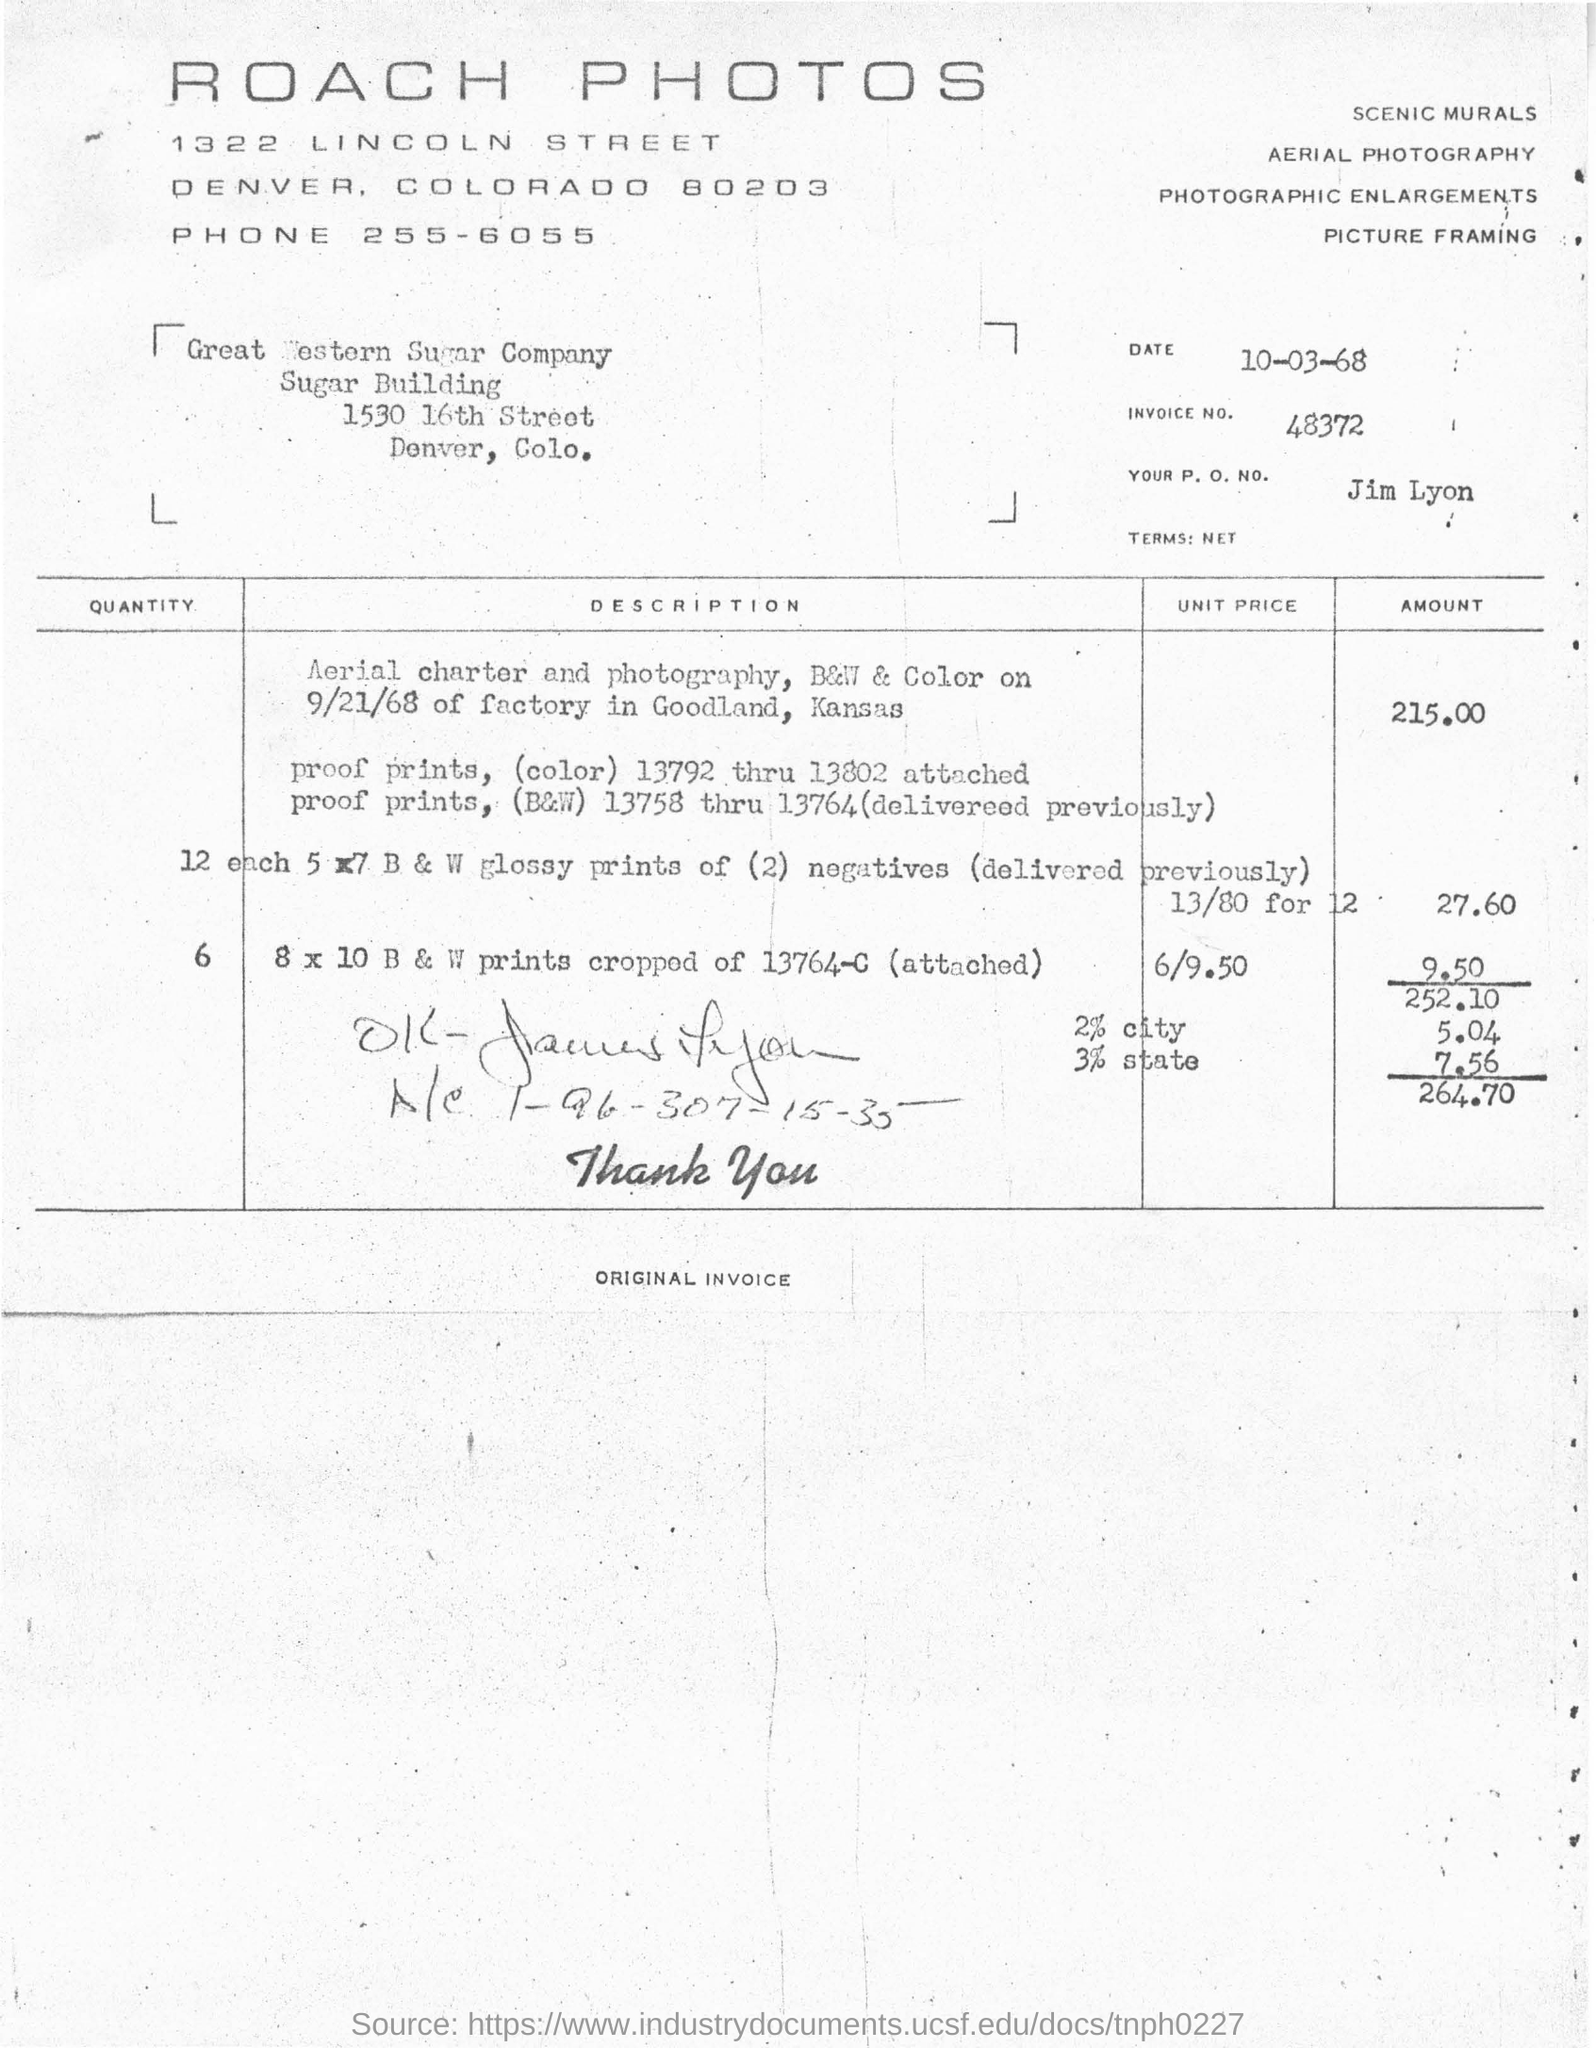What is the date mentioned in the invoice?
Give a very brief answer. 10-03-68. What is the invoice no. given in the document?
Make the answer very short. 48372. Which company is raising the invoice?
Your answer should be very brief. ROACH PHOTOS. What is the payee's name given in the invoice?
Offer a terse response. Great Western Sugar Company. What is the total invoice amount given in the document?
Your answer should be compact. 264.70. 